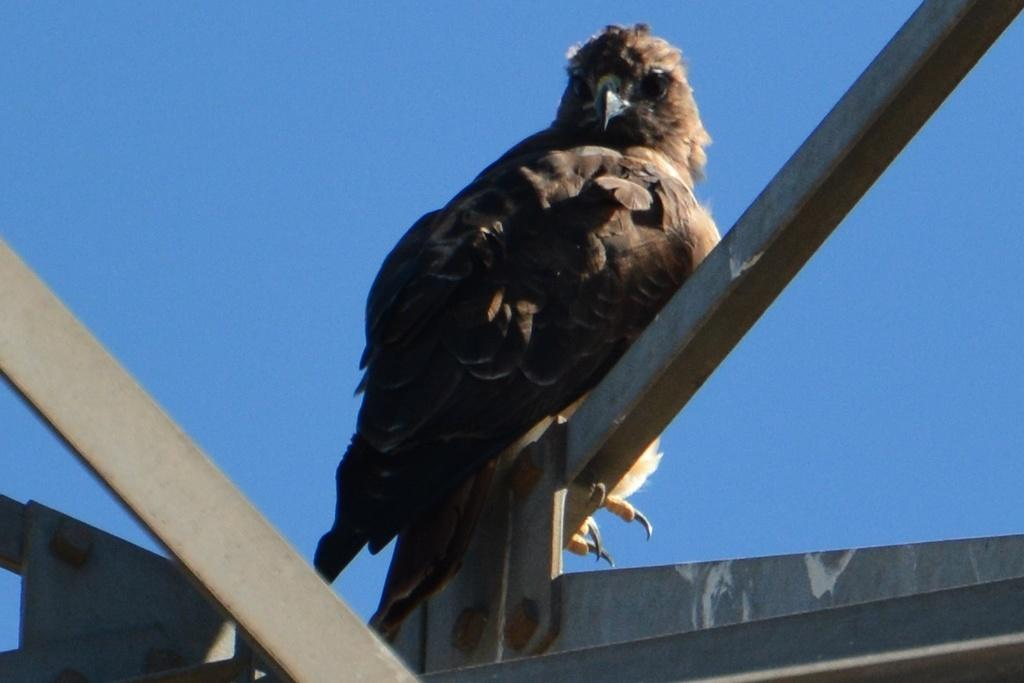What material is the main object in the image made of? The main object in the image is made up of wood. Can you describe the bird in the image? The bird is standing on the wooden object. What type of zoo animal can be seen in the image? There is no zoo animal present in the image; only a bird and a wooden object are visible. What suggestion does the porter have for improving the image? There is no porter present in the image, and therefore no suggestion can be provided. 